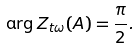Convert formula to latex. <formula><loc_0><loc_0><loc_500><loc_500>\arg Z _ { t \omega } ( A ) = \frac { \pi } { 2 } .</formula> 